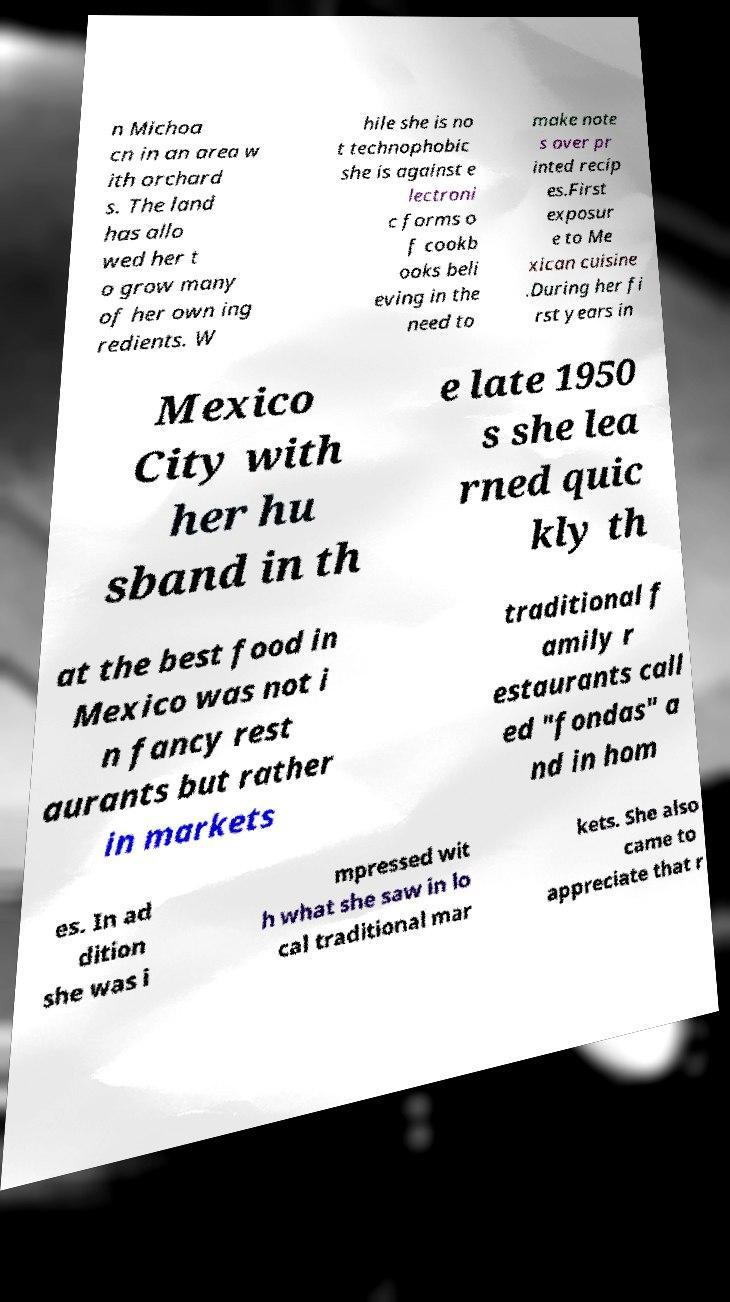Please read and relay the text visible in this image. What does it say? n Michoa cn in an area w ith orchard s. The land has allo wed her t o grow many of her own ing redients. W hile she is no t technophobic she is against e lectroni c forms o f cookb ooks beli eving in the need to make note s over pr inted recip es.First exposur e to Me xican cuisine .During her fi rst years in Mexico City with her hu sband in th e late 1950 s she lea rned quic kly th at the best food in Mexico was not i n fancy rest aurants but rather in markets traditional f amily r estaurants call ed "fondas" a nd in hom es. In ad dition she was i mpressed wit h what she saw in lo cal traditional mar kets. She also came to appreciate that r 